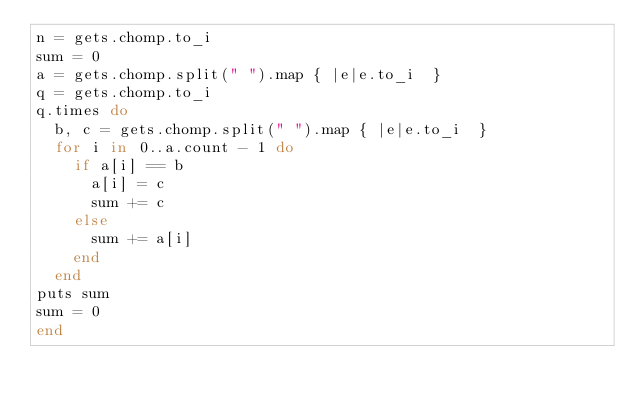<code> <loc_0><loc_0><loc_500><loc_500><_Ruby_>n = gets.chomp.to_i
sum = 0
a = gets.chomp.split(" ").map { |e|e.to_i  }
q = gets.chomp.to_i
q.times do
  b, c = gets.chomp.split(" ").map { |e|e.to_i  }
  for i in 0..a.count - 1 do
    if a[i] == b
      a[i] = c
      sum += c
    else
      sum += a[i]
    end
  end
puts sum
sum = 0
end
</code> 